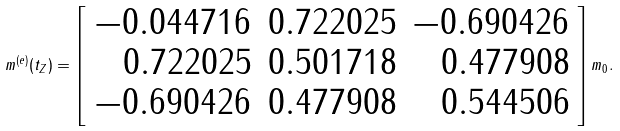<formula> <loc_0><loc_0><loc_500><loc_500>m ^ { ( e ) } ( t _ { Z } ) = \left [ \begin{array} { r r r } - 0 . 0 4 4 7 1 6 & 0 . 7 2 2 0 2 5 & - 0 . 6 9 0 4 2 6 \\ 0 . 7 2 2 0 2 5 & 0 . 5 0 1 7 1 8 & 0 . 4 7 7 9 0 8 \\ - 0 . 6 9 0 4 2 6 & 0 . 4 7 7 9 0 8 & 0 . 5 4 4 5 0 6 \end{array} \right ] m _ { 0 } .</formula> 